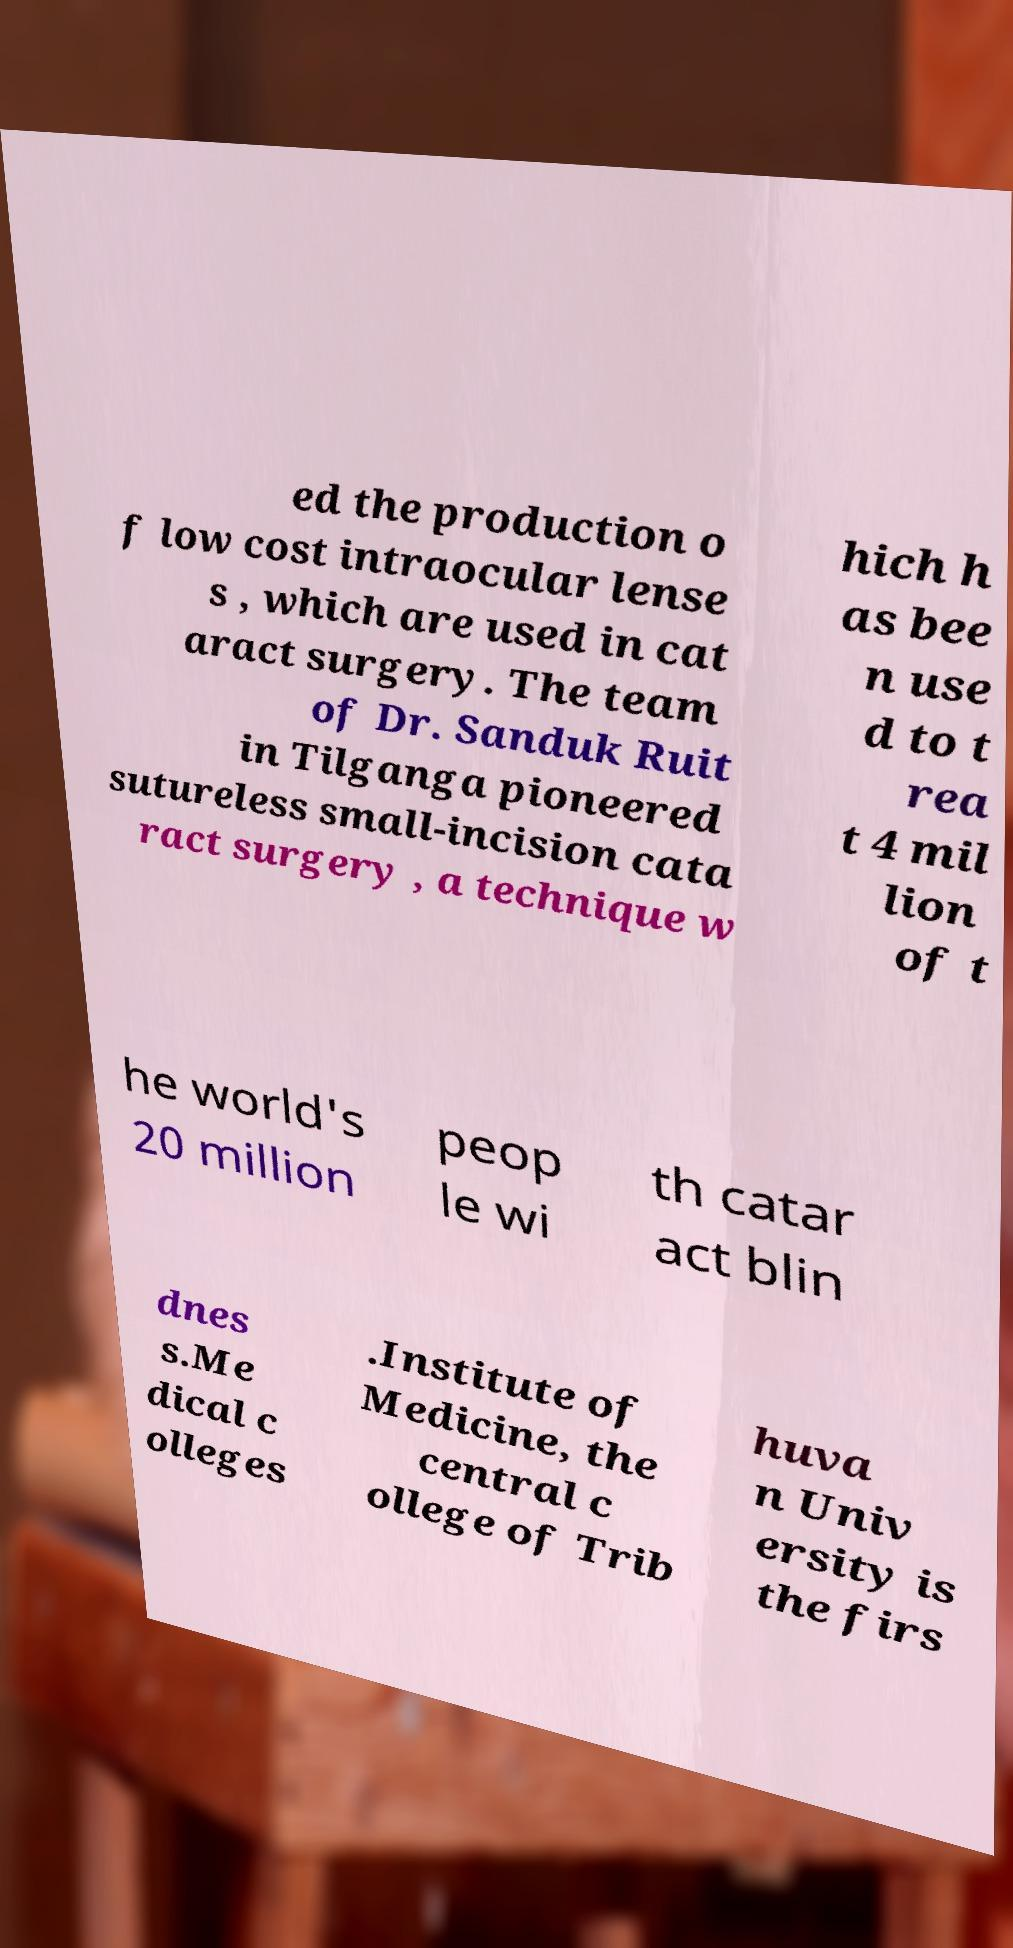Can you read and provide the text displayed in the image?This photo seems to have some interesting text. Can you extract and type it out for me? ed the production o f low cost intraocular lense s , which are used in cat aract surgery. The team of Dr. Sanduk Ruit in Tilganga pioneered sutureless small-incision cata ract surgery , a technique w hich h as bee n use d to t rea t 4 mil lion of t he world's 20 million peop le wi th catar act blin dnes s.Me dical c olleges .Institute of Medicine, the central c ollege of Trib huva n Univ ersity is the firs 